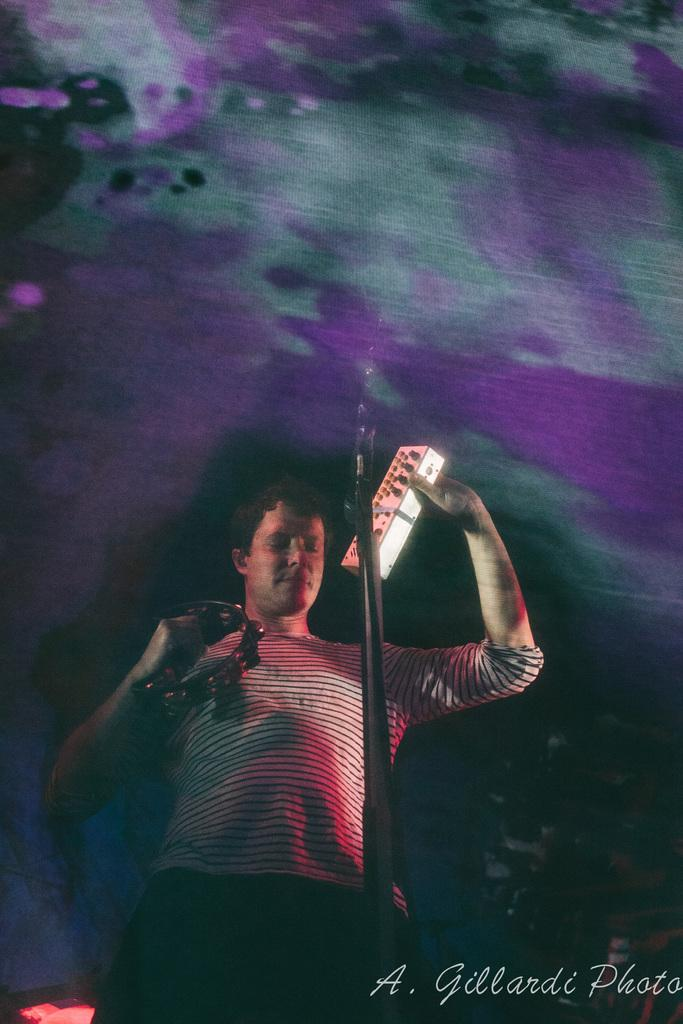Who is the main subject in the image? There is a person in the image. What is the person doing in the image? The person is standing in front of a mic. What is the person holding in his hand? The person is holding objects in his hand. What additional information can be found at the bottom of the image? There is text at the bottom of the image. Can you tell me how many women are present in the image? There is no woman present in the image; it features a person who appears to be male. What type of blade is being used by the person in the image? There is no blade visible in the image; the person is holding objects, but they do not appear to be blades. 